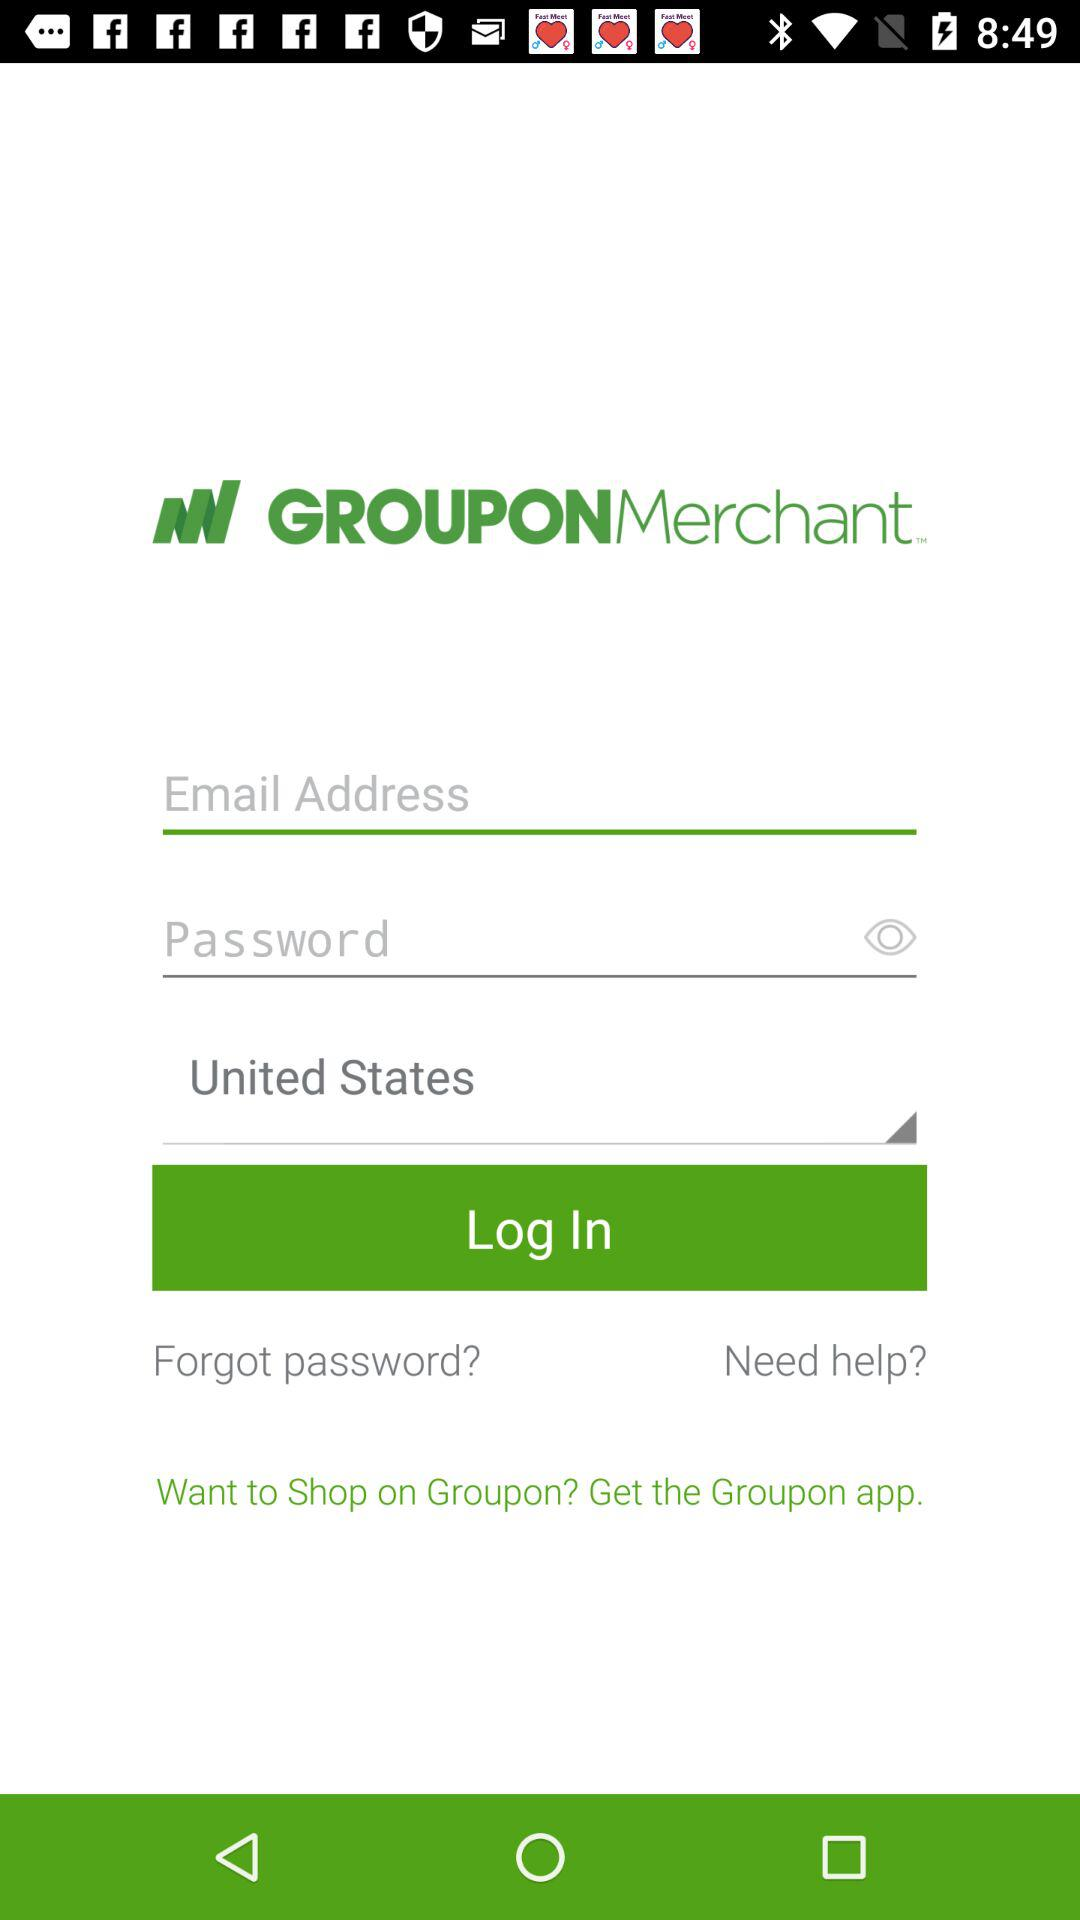Which country has been selected? The selected country is the United States. 